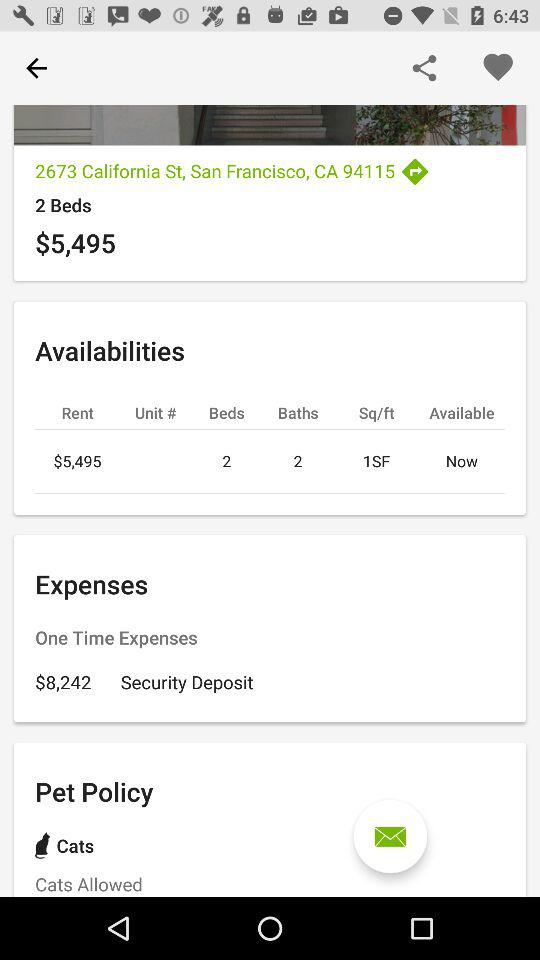What is the current location? The current location is 2673 California St, San Francisco, CA 94115. 